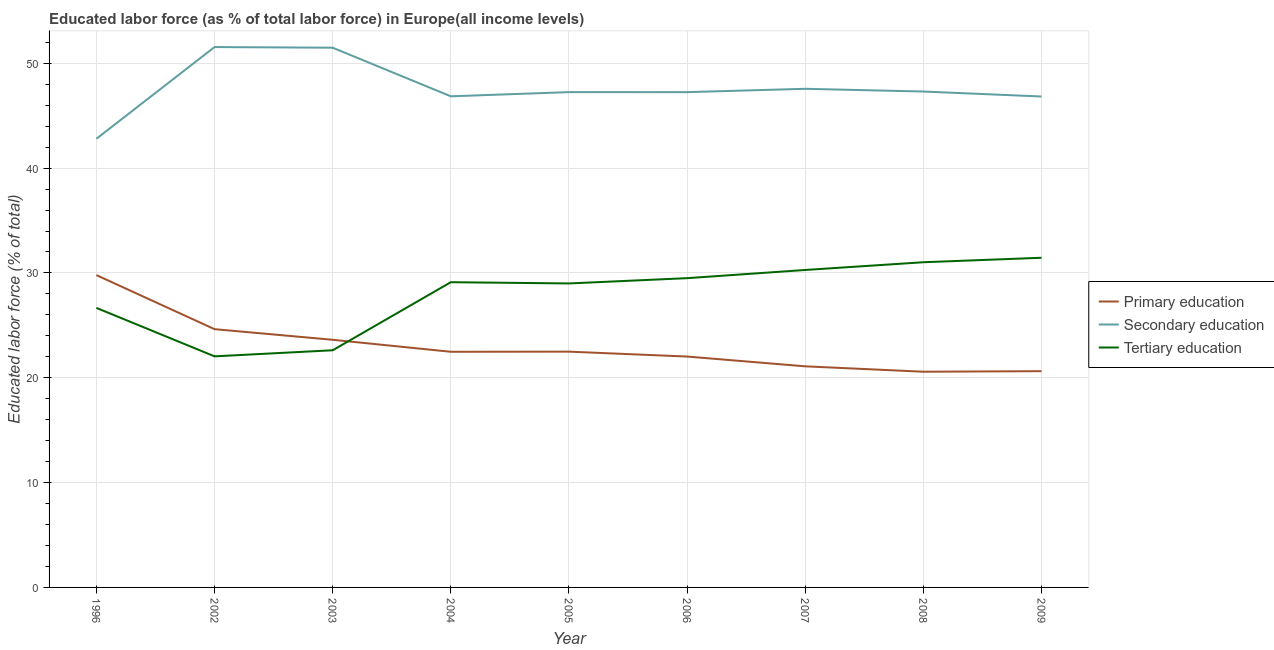How many different coloured lines are there?
Make the answer very short. 3. Is the number of lines equal to the number of legend labels?
Your answer should be very brief. Yes. What is the percentage of labor force who received tertiary education in 2005?
Your answer should be very brief. 29. Across all years, what is the maximum percentage of labor force who received tertiary education?
Offer a terse response. 31.45. Across all years, what is the minimum percentage of labor force who received tertiary education?
Offer a terse response. 22.04. In which year was the percentage of labor force who received primary education maximum?
Provide a succinct answer. 1996. What is the total percentage of labor force who received secondary education in the graph?
Offer a very short reply. 428.87. What is the difference between the percentage of labor force who received secondary education in 2002 and that in 2008?
Your response must be concise. 4.24. What is the difference between the percentage of labor force who received secondary education in 2008 and the percentage of labor force who received tertiary education in 2009?
Your answer should be compact. 15.86. What is the average percentage of labor force who received primary education per year?
Ensure brevity in your answer.  23.04. In the year 2004, what is the difference between the percentage of labor force who received secondary education and percentage of labor force who received tertiary education?
Your response must be concise. 17.73. In how many years, is the percentage of labor force who received secondary education greater than 50 %?
Ensure brevity in your answer.  2. What is the ratio of the percentage of labor force who received tertiary education in 2003 to that in 2004?
Your answer should be very brief. 0.78. Is the percentage of labor force who received secondary education in 2003 less than that in 2006?
Provide a short and direct response. No. What is the difference between the highest and the second highest percentage of labor force who received primary education?
Your answer should be very brief. 5.16. What is the difference between the highest and the lowest percentage of labor force who received primary education?
Make the answer very short. 9.22. In how many years, is the percentage of labor force who received secondary education greater than the average percentage of labor force who received secondary education taken over all years?
Your answer should be very brief. 2. Is the sum of the percentage of labor force who received secondary education in 1996 and 2008 greater than the maximum percentage of labor force who received primary education across all years?
Ensure brevity in your answer.  Yes. Is the percentage of labor force who received secondary education strictly less than the percentage of labor force who received tertiary education over the years?
Keep it short and to the point. No. How many lines are there?
Offer a very short reply. 3. What is the difference between two consecutive major ticks on the Y-axis?
Your answer should be compact. 10. Does the graph contain grids?
Your answer should be very brief. Yes. How many legend labels are there?
Your response must be concise. 3. What is the title of the graph?
Keep it short and to the point. Educated labor force (as % of total labor force) in Europe(all income levels). Does "Male employers" appear as one of the legend labels in the graph?
Offer a terse response. No. What is the label or title of the Y-axis?
Offer a very short reply. Educated labor force (% of total). What is the Educated labor force (% of total) of Primary education in 1996?
Offer a very short reply. 29.79. What is the Educated labor force (% of total) of Secondary education in 1996?
Your answer should be compact. 42.8. What is the Educated labor force (% of total) in Tertiary education in 1996?
Offer a very short reply. 26.66. What is the Educated labor force (% of total) of Primary education in 2002?
Offer a terse response. 24.64. What is the Educated labor force (% of total) of Secondary education in 2002?
Give a very brief answer. 51.55. What is the Educated labor force (% of total) in Tertiary education in 2002?
Your answer should be compact. 22.04. What is the Educated labor force (% of total) in Primary education in 2003?
Your answer should be compact. 23.62. What is the Educated labor force (% of total) in Secondary education in 2003?
Your response must be concise. 51.49. What is the Educated labor force (% of total) of Tertiary education in 2003?
Ensure brevity in your answer.  22.62. What is the Educated labor force (% of total) of Primary education in 2004?
Your answer should be compact. 22.48. What is the Educated labor force (% of total) of Secondary education in 2004?
Ensure brevity in your answer.  46.85. What is the Educated labor force (% of total) of Tertiary education in 2004?
Provide a succinct answer. 29.12. What is the Educated labor force (% of total) of Primary education in 2005?
Offer a very short reply. 22.49. What is the Educated labor force (% of total) of Secondary education in 2005?
Offer a very short reply. 47.25. What is the Educated labor force (% of total) of Tertiary education in 2005?
Make the answer very short. 29. What is the Educated labor force (% of total) of Primary education in 2006?
Provide a short and direct response. 22.02. What is the Educated labor force (% of total) in Secondary education in 2006?
Your answer should be compact. 47.25. What is the Educated labor force (% of total) of Tertiary education in 2006?
Your response must be concise. 29.5. What is the Educated labor force (% of total) of Primary education in 2007?
Keep it short and to the point. 21.09. What is the Educated labor force (% of total) of Secondary education in 2007?
Make the answer very short. 47.57. What is the Educated labor force (% of total) of Tertiary education in 2007?
Ensure brevity in your answer.  30.28. What is the Educated labor force (% of total) of Primary education in 2008?
Give a very brief answer. 20.58. What is the Educated labor force (% of total) in Secondary education in 2008?
Offer a terse response. 47.3. What is the Educated labor force (% of total) in Tertiary education in 2008?
Ensure brevity in your answer.  31.02. What is the Educated labor force (% of total) of Primary education in 2009?
Make the answer very short. 20.63. What is the Educated labor force (% of total) of Secondary education in 2009?
Provide a succinct answer. 46.83. What is the Educated labor force (% of total) of Tertiary education in 2009?
Provide a short and direct response. 31.45. Across all years, what is the maximum Educated labor force (% of total) of Primary education?
Provide a succinct answer. 29.79. Across all years, what is the maximum Educated labor force (% of total) in Secondary education?
Provide a succinct answer. 51.55. Across all years, what is the maximum Educated labor force (% of total) of Tertiary education?
Your answer should be very brief. 31.45. Across all years, what is the minimum Educated labor force (% of total) of Primary education?
Keep it short and to the point. 20.58. Across all years, what is the minimum Educated labor force (% of total) in Secondary education?
Ensure brevity in your answer.  42.8. Across all years, what is the minimum Educated labor force (% of total) of Tertiary education?
Provide a short and direct response. 22.04. What is the total Educated labor force (% of total) in Primary education in the graph?
Your response must be concise. 207.34. What is the total Educated labor force (% of total) of Secondary education in the graph?
Offer a very short reply. 428.87. What is the total Educated labor force (% of total) of Tertiary education in the graph?
Your answer should be very brief. 251.7. What is the difference between the Educated labor force (% of total) in Primary education in 1996 and that in 2002?
Provide a short and direct response. 5.16. What is the difference between the Educated labor force (% of total) in Secondary education in 1996 and that in 2002?
Give a very brief answer. -8.75. What is the difference between the Educated labor force (% of total) of Tertiary education in 1996 and that in 2002?
Keep it short and to the point. 4.62. What is the difference between the Educated labor force (% of total) in Primary education in 1996 and that in 2003?
Provide a succinct answer. 6.17. What is the difference between the Educated labor force (% of total) of Secondary education in 1996 and that in 2003?
Your response must be concise. -8.69. What is the difference between the Educated labor force (% of total) of Tertiary education in 1996 and that in 2003?
Provide a short and direct response. 4.04. What is the difference between the Educated labor force (% of total) of Primary education in 1996 and that in 2004?
Give a very brief answer. 7.31. What is the difference between the Educated labor force (% of total) of Secondary education in 1996 and that in 2004?
Keep it short and to the point. -4.05. What is the difference between the Educated labor force (% of total) in Tertiary education in 1996 and that in 2004?
Give a very brief answer. -2.45. What is the difference between the Educated labor force (% of total) of Primary education in 1996 and that in 2005?
Give a very brief answer. 7.3. What is the difference between the Educated labor force (% of total) of Secondary education in 1996 and that in 2005?
Provide a short and direct response. -4.45. What is the difference between the Educated labor force (% of total) of Tertiary education in 1996 and that in 2005?
Provide a short and direct response. -2.33. What is the difference between the Educated labor force (% of total) in Primary education in 1996 and that in 2006?
Your answer should be compact. 7.77. What is the difference between the Educated labor force (% of total) in Secondary education in 1996 and that in 2006?
Provide a short and direct response. -4.45. What is the difference between the Educated labor force (% of total) of Tertiary education in 1996 and that in 2006?
Ensure brevity in your answer.  -2.84. What is the difference between the Educated labor force (% of total) of Primary education in 1996 and that in 2007?
Make the answer very short. 8.7. What is the difference between the Educated labor force (% of total) in Secondary education in 1996 and that in 2007?
Provide a short and direct response. -4.77. What is the difference between the Educated labor force (% of total) in Tertiary education in 1996 and that in 2007?
Your answer should be very brief. -3.62. What is the difference between the Educated labor force (% of total) of Primary education in 1996 and that in 2008?
Your answer should be very brief. 9.22. What is the difference between the Educated labor force (% of total) of Secondary education in 1996 and that in 2008?
Your response must be concise. -4.51. What is the difference between the Educated labor force (% of total) of Tertiary education in 1996 and that in 2008?
Offer a very short reply. -4.36. What is the difference between the Educated labor force (% of total) of Primary education in 1996 and that in 2009?
Keep it short and to the point. 9.17. What is the difference between the Educated labor force (% of total) in Secondary education in 1996 and that in 2009?
Make the answer very short. -4.04. What is the difference between the Educated labor force (% of total) of Tertiary education in 1996 and that in 2009?
Your response must be concise. -4.78. What is the difference between the Educated labor force (% of total) in Primary education in 2002 and that in 2003?
Offer a terse response. 1.01. What is the difference between the Educated labor force (% of total) of Secondary education in 2002 and that in 2003?
Keep it short and to the point. 0.06. What is the difference between the Educated labor force (% of total) of Tertiary education in 2002 and that in 2003?
Keep it short and to the point. -0.58. What is the difference between the Educated labor force (% of total) in Primary education in 2002 and that in 2004?
Make the answer very short. 2.16. What is the difference between the Educated labor force (% of total) in Secondary education in 2002 and that in 2004?
Your response must be concise. 4.7. What is the difference between the Educated labor force (% of total) of Tertiary education in 2002 and that in 2004?
Keep it short and to the point. -7.07. What is the difference between the Educated labor force (% of total) in Primary education in 2002 and that in 2005?
Offer a very short reply. 2.14. What is the difference between the Educated labor force (% of total) of Secondary education in 2002 and that in 2005?
Provide a short and direct response. 4.3. What is the difference between the Educated labor force (% of total) in Tertiary education in 2002 and that in 2005?
Ensure brevity in your answer.  -6.95. What is the difference between the Educated labor force (% of total) of Primary education in 2002 and that in 2006?
Offer a very short reply. 2.61. What is the difference between the Educated labor force (% of total) in Secondary education in 2002 and that in 2006?
Your response must be concise. 4.3. What is the difference between the Educated labor force (% of total) of Tertiary education in 2002 and that in 2006?
Offer a very short reply. -7.46. What is the difference between the Educated labor force (% of total) of Primary education in 2002 and that in 2007?
Offer a terse response. 3.54. What is the difference between the Educated labor force (% of total) of Secondary education in 2002 and that in 2007?
Offer a terse response. 3.98. What is the difference between the Educated labor force (% of total) of Tertiary education in 2002 and that in 2007?
Ensure brevity in your answer.  -8.24. What is the difference between the Educated labor force (% of total) in Primary education in 2002 and that in 2008?
Provide a succinct answer. 4.06. What is the difference between the Educated labor force (% of total) in Secondary education in 2002 and that in 2008?
Offer a very short reply. 4.24. What is the difference between the Educated labor force (% of total) of Tertiary education in 2002 and that in 2008?
Offer a terse response. -8.98. What is the difference between the Educated labor force (% of total) of Primary education in 2002 and that in 2009?
Ensure brevity in your answer.  4.01. What is the difference between the Educated labor force (% of total) of Secondary education in 2002 and that in 2009?
Your answer should be compact. 4.72. What is the difference between the Educated labor force (% of total) in Tertiary education in 2002 and that in 2009?
Offer a terse response. -9.4. What is the difference between the Educated labor force (% of total) of Primary education in 2003 and that in 2004?
Keep it short and to the point. 1.14. What is the difference between the Educated labor force (% of total) of Secondary education in 2003 and that in 2004?
Your answer should be very brief. 4.64. What is the difference between the Educated labor force (% of total) of Tertiary education in 2003 and that in 2004?
Make the answer very short. -6.49. What is the difference between the Educated labor force (% of total) in Primary education in 2003 and that in 2005?
Provide a succinct answer. 1.13. What is the difference between the Educated labor force (% of total) in Secondary education in 2003 and that in 2005?
Give a very brief answer. 4.24. What is the difference between the Educated labor force (% of total) in Tertiary education in 2003 and that in 2005?
Ensure brevity in your answer.  -6.38. What is the difference between the Educated labor force (% of total) of Primary education in 2003 and that in 2006?
Make the answer very short. 1.6. What is the difference between the Educated labor force (% of total) in Secondary education in 2003 and that in 2006?
Offer a very short reply. 4.24. What is the difference between the Educated labor force (% of total) in Tertiary education in 2003 and that in 2006?
Your answer should be very brief. -6.88. What is the difference between the Educated labor force (% of total) of Primary education in 2003 and that in 2007?
Give a very brief answer. 2.53. What is the difference between the Educated labor force (% of total) of Secondary education in 2003 and that in 2007?
Give a very brief answer. 3.92. What is the difference between the Educated labor force (% of total) in Tertiary education in 2003 and that in 2007?
Your answer should be compact. -7.66. What is the difference between the Educated labor force (% of total) of Primary education in 2003 and that in 2008?
Your answer should be very brief. 3.05. What is the difference between the Educated labor force (% of total) in Secondary education in 2003 and that in 2008?
Offer a very short reply. 4.18. What is the difference between the Educated labor force (% of total) of Tertiary education in 2003 and that in 2008?
Your answer should be compact. -8.4. What is the difference between the Educated labor force (% of total) in Primary education in 2003 and that in 2009?
Your answer should be compact. 3. What is the difference between the Educated labor force (% of total) of Secondary education in 2003 and that in 2009?
Offer a terse response. 4.65. What is the difference between the Educated labor force (% of total) of Tertiary education in 2003 and that in 2009?
Ensure brevity in your answer.  -8.82. What is the difference between the Educated labor force (% of total) of Primary education in 2004 and that in 2005?
Make the answer very short. -0.01. What is the difference between the Educated labor force (% of total) of Secondary education in 2004 and that in 2005?
Provide a succinct answer. -0.4. What is the difference between the Educated labor force (% of total) in Tertiary education in 2004 and that in 2005?
Your answer should be compact. 0.12. What is the difference between the Educated labor force (% of total) in Primary education in 2004 and that in 2006?
Give a very brief answer. 0.46. What is the difference between the Educated labor force (% of total) of Secondary education in 2004 and that in 2006?
Provide a short and direct response. -0.4. What is the difference between the Educated labor force (% of total) of Tertiary education in 2004 and that in 2006?
Your answer should be compact. -0.38. What is the difference between the Educated labor force (% of total) of Primary education in 2004 and that in 2007?
Ensure brevity in your answer.  1.39. What is the difference between the Educated labor force (% of total) of Secondary education in 2004 and that in 2007?
Your answer should be very brief. -0.72. What is the difference between the Educated labor force (% of total) in Tertiary education in 2004 and that in 2007?
Ensure brevity in your answer.  -1.17. What is the difference between the Educated labor force (% of total) of Primary education in 2004 and that in 2008?
Provide a short and direct response. 1.9. What is the difference between the Educated labor force (% of total) in Secondary education in 2004 and that in 2008?
Offer a very short reply. -0.46. What is the difference between the Educated labor force (% of total) of Tertiary education in 2004 and that in 2008?
Offer a very short reply. -1.9. What is the difference between the Educated labor force (% of total) of Primary education in 2004 and that in 2009?
Keep it short and to the point. 1.85. What is the difference between the Educated labor force (% of total) of Secondary education in 2004 and that in 2009?
Provide a short and direct response. 0.02. What is the difference between the Educated labor force (% of total) in Tertiary education in 2004 and that in 2009?
Offer a very short reply. -2.33. What is the difference between the Educated labor force (% of total) of Primary education in 2005 and that in 2006?
Offer a very short reply. 0.47. What is the difference between the Educated labor force (% of total) in Secondary education in 2005 and that in 2006?
Offer a very short reply. 0. What is the difference between the Educated labor force (% of total) of Tertiary education in 2005 and that in 2006?
Make the answer very short. -0.5. What is the difference between the Educated labor force (% of total) of Primary education in 2005 and that in 2007?
Provide a short and direct response. 1.4. What is the difference between the Educated labor force (% of total) of Secondary education in 2005 and that in 2007?
Offer a very short reply. -0.32. What is the difference between the Educated labor force (% of total) in Tertiary education in 2005 and that in 2007?
Ensure brevity in your answer.  -1.28. What is the difference between the Educated labor force (% of total) of Primary education in 2005 and that in 2008?
Your answer should be very brief. 1.91. What is the difference between the Educated labor force (% of total) of Secondary education in 2005 and that in 2008?
Provide a short and direct response. -0.06. What is the difference between the Educated labor force (% of total) of Tertiary education in 2005 and that in 2008?
Your answer should be compact. -2.02. What is the difference between the Educated labor force (% of total) in Primary education in 2005 and that in 2009?
Give a very brief answer. 1.86. What is the difference between the Educated labor force (% of total) of Secondary education in 2005 and that in 2009?
Make the answer very short. 0.42. What is the difference between the Educated labor force (% of total) in Tertiary education in 2005 and that in 2009?
Give a very brief answer. -2.45. What is the difference between the Educated labor force (% of total) of Primary education in 2006 and that in 2007?
Provide a short and direct response. 0.93. What is the difference between the Educated labor force (% of total) in Secondary education in 2006 and that in 2007?
Provide a short and direct response. -0.32. What is the difference between the Educated labor force (% of total) of Tertiary education in 2006 and that in 2007?
Your response must be concise. -0.78. What is the difference between the Educated labor force (% of total) of Primary education in 2006 and that in 2008?
Ensure brevity in your answer.  1.45. What is the difference between the Educated labor force (% of total) in Secondary education in 2006 and that in 2008?
Provide a succinct answer. -0.06. What is the difference between the Educated labor force (% of total) in Tertiary education in 2006 and that in 2008?
Offer a terse response. -1.52. What is the difference between the Educated labor force (% of total) in Primary education in 2006 and that in 2009?
Ensure brevity in your answer.  1.4. What is the difference between the Educated labor force (% of total) of Secondary education in 2006 and that in 2009?
Ensure brevity in your answer.  0.42. What is the difference between the Educated labor force (% of total) in Tertiary education in 2006 and that in 2009?
Make the answer very short. -1.95. What is the difference between the Educated labor force (% of total) of Primary education in 2007 and that in 2008?
Your answer should be very brief. 0.51. What is the difference between the Educated labor force (% of total) of Secondary education in 2007 and that in 2008?
Offer a terse response. 0.26. What is the difference between the Educated labor force (% of total) of Tertiary education in 2007 and that in 2008?
Your answer should be compact. -0.74. What is the difference between the Educated labor force (% of total) in Primary education in 2007 and that in 2009?
Provide a short and direct response. 0.46. What is the difference between the Educated labor force (% of total) in Secondary education in 2007 and that in 2009?
Your answer should be very brief. 0.73. What is the difference between the Educated labor force (% of total) of Tertiary education in 2007 and that in 2009?
Make the answer very short. -1.16. What is the difference between the Educated labor force (% of total) in Primary education in 2008 and that in 2009?
Keep it short and to the point. -0.05. What is the difference between the Educated labor force (% of total) of Secondary education in 2008 and that in 2009?
Provide a succinct answer. 0.47. What is the difference between the Educated labor force (% of total) in Tertiary education in 2008 and that in 2009?
Offer a very short reply. -0.43. What is the difference between the Educated labor force (% of total) in Primary education in 1996 and the Educated labor force (% of total) in Secondary education in 2002?
Make the answer very short. -21.75. What is the difference between the Educated labor force (% of total) of Primary education in 1996 and the Educated labor force (% of total) of Tertiary education in 2002?
Offer a very short reply. 7.75. What is the difference between the Educated labor force (% of total) in Secondary education in 1996 and the Educated labor force (% of total) in Tertiary education in 2002?
Ensure brevity in your answer.  20.75. What is the difference between the Educated labor force (% of total) in Primary education in 1996 and the Educated labor force (% of total) in Secondary education in 2003?
Offer a terse response. -21.69. What is the difference between the Educated labor force (% of total) in Primary education in 1996 and the Educated labor force (% of total) in Tertiary education in 2003?
Make the answer very short. 7.17. What is the difference between the Educated labor force (% of total) of Secondary education in 1996 and the Educated labor force (% of total) of Tertiary education in 2003?
Your response must be concise. 20.17. What is the difference between the Educated labor force (% of total) in Primary education in 1996 and the Educated labor force (% of total) in Secondary education in 2004?
Provide a succinct answer. -17.05. What is the difference between the Educated labor force (% of total) in Primary education in 1996 and the Educated labor force (% of total) in Tertiary education in 2004?
Give a very brief answer. 0.68. What is the difference between the Educated labor force (% of total) of Secondary education in 1996 and the Educated labor force (% of total) of Tertiary education in 2004?
Keep it short and to the point. 13.68. What is the difference between the Educated labor force (% of total) in Primary education in 1996 and the Educated labor force (% of total) in Secondary education in 2005?
Your answer should be compact. -17.45. What is the difference between the Educated labor force (% of total) of Primary education in 1996 and the Educated labor force (% of total) of Tertiary education in 2005?
Your answer should be very brief. 0.8. What is the difference between the Educated labor force (% of total) in Secondary education in 1996 and the Educated labor force (% of total) in Tertiary education in 2005?
Make the answer very short. 13.8. What is the difference between the Educated labor force (% of total) of Primary education in 1996 and the Educated labor force (% of total) of Secondary education in 2006?
Your answer should be compact. -17.45. What is the difference between the Educated labor force (% of total) in Primary education in 1996 and the Educated labor force (% of total) in Tertiary education in 2006?
Ensure brevity in your answer.  0.29. What is the difference between the Educated labor force (% of total) in Secondary education in 1996 and the Educated labor force (% of total) in Tertiary education in 2006?
Your answer should be very brief. 13.3. What is the difference between the Educated labor force (% of total) in Primary education in 1996 and the Educated labor force (% of total) in Secondary education in 2007?
Your answer should be compact. -17.77. What is the difference between the Educated labor force (% of total) in Primary education in 1996 and the Educated labor force (% of total) in Tertiary education in 2007?
Keep it short and to the point. -0.49. What is the difference between the Educated labor force (% of total) in Secondary education in 1996 and the Educated labor force (% of total) in Tertiary education in 2007?
Keep it short and to the point. 12.51. What is the difference between the Educated labor force (% of total) of Primary education in 1996 and the Educated labor force (% of total) of Secondary education in 2008?
Make the answer very short. -17.51. What is the difference between the Educated labor force (% of total) in Primary education in 1996 and the Educated labor force (% of total) in Tertiary education in 2008?
Your answer should be compact. -1.23. What is the difference between the Educated labor force (% of total) of Secondary education in 1996 and the Educated labor force (% of total) of Tertiary education in 2008?
Your answer should be very brief. 11.78. What is the difference between the Educated labor force (% of total) in Primary education in 1996 and the Educated labor force (% of total) in Secondary education in 2009?
Give a very brief answer. -17.04. What is the difference between the Educated labor force (% of total) in Primary education in 1996 and the Educated labor force (% of total) in Tertiary education in 2009?
Offer a terse response. -1.65. What is the difference between the Educated labor force (% of total) in Secondary education in 1996 and the Educated labor force (% of total) in Tertiary education in 2009?
Give a very brief answer. 11.35. What is the difference between the Educated labor force (% of total) of Primary education in 2002 and the Educated labor force (% of total) of Secondary education in 2003?
Ensure brevity in your answer.  -26.85. What is the difference between the Educated labor force (% of total) in Primary education in 2002 and the Educated labor force (% of total) in Tertiary education in 2003?
Offer a very short reply. 2.01. What is the difference between the Educated labor force (% of total) in Secondary education in 2002 and the Educated labor force (% of total) in Tertiary education in 2003?
Give a very brief answer. 28.92. What is the difference between the Educated labor force (% of total) in Primary education in 2002 and the Educated labor force (% of total) in Secondary education in 2004?
Offer a terse response. -22.21. What is the difference between the Educated labor force (% of total) of Primary education in 2002 and the Educated labor force (% of total) of Tertiary education in 2004?
Make the answer very short. -4.48. What is the difference between the Educated labor force (% of total) in Secondary education in 2002 and the Educated labor force (% of total) in Tertiary education in 2004?
Provide a succinct answer. 22.43. What is the difference between the Educated labor force (% of total) of Primary education in 2002 and the Educated labor force (% of total) of Secondary education in 2005?
Provide a succinct answer. -22.61. What is the difference between the Educated labor force (% of total) in Primary education in 2002 and the Educated labor force (% of total) in Tertiary education in 2005?
Make the answer very short. -4.36. What is the difference between the Educated labor force (% of total) in Secondary education in 2002 and the Educated labor force (% of total) in Tertiary education in 2005?
Offer a very short reply. 22.55. What is the difference between the Educated labor force (% of total) of Primary education in 2002 and the Educated labor force (% of total) of Secondary education in 2006?
Offer a very short reply. -22.61. What is the difference between the Educated labor force (% of total) in Primary education in 2002 and the Educated labor force (% of total) in Tertiary education in 2006?
Ensure brevity in your answer.  -4.86. What is the difference between the Educated labor force (% of total) of Secondary education in 2002 and the Educated labor force (% of total) of Tertiary education in 2006?
Provide a succinct answer. 22.05. What is the difference between the Educated labor force (% of total) of Primary education in 2002 and the Educated labor force (% of total) of Secondary education in 2007?
Ensure brevity in your answer.  -22.93. What is the difference between the Educated labor force (% of total) in Primary education in 2002 and the Educated labor force (% of total) in Tertiary education in 2007?
Your answer should be very brief. -5.65. What is the difference between the Educated labor force (% of total) of Secondary education in 2002 and the Educated labor force (% of total) of Tertiary education in 2007?
Offer a very short reply. 21.26. What is the difference between the Educated labor force (% of total) in Primary education in 2002 and the Educated labor force (% of total) in Secondary education in 2008?
Keep it short and to the point. -22.67. What is the difference between the Educated labor force (% of total) in Primary education in 2002 and the Educated labor force (% of total) in Tertiary education in 2008?
Offer a very short reply. -6.38. What is the difference between the Educated labor force (% of total) of Secondary education in 2002 and the Educated labor force (% of total) of Tertiary education in 2008?
Offer a terse response. 20.53. What is the difference between the Educated labor force (% of total) of Primary education in 2002 and the Educated labor force (% of total) of Secondary education in 2009?
Your response must be concise. -22.2. What is the difference between the Educated labor force (% of total) in Primary education in 2002 and the Educated labor force (% of total) in Tertiary education in 2009?
Keep it short and to the point. -6.81. What is the difference between the Educated labor force (% of total) in Secondary education in 2002 and the Educated labor force (% of total) in Tertiary education in 2009?
Ensure brevity in your answer.  20.1. What is the difference between the Educated labor force (% of total) in Primary education in 2003 and the Educated labor force (% of total) in Secondary education in 2004?
Give a very brief answer. -23.22. What is the difference between the Educated labor force (% of total) in Primary education in 2003 and the Educated labor force (% of total) in Tertiary education in 2004?
Give a very brief answer. -5.49. What is the difference between the Educated labor force (% of total) of Secondary education in 2003 and the Educated labor force (% of total) of Tertiary education in 2004?
Keep it short and to the point. 22.37. What is the difference between the Educated labor force (% of total) in Primary education in 2003 and the Educated labor force (% of total) in Secondary education in 2005?
Ensure brevity in your answer.  -23.62. What is the difference between the Educated labor force (% of total) in Primary education in 2003 and the Educated labor force (% of total) in Tertiary education in 2005?
Your response must be concise. -5.37. What is the difference between the Educated labor force (% of total) in Secondary education in 2003 and the Educated labor force (% of total) in Tertiary education in 2005?
Provide a succinct answer. 22.49. What is the difference between the Educated labor force (% of total) of Primary education in 2003 and the Educated labor force (% of total) of Secondary education in 2006?
Offer a very short reply. -23.62. What is the difference between the Educated labor force (% of total) in Primary education in 2003 and the Educated labor force (% of total) in Tertiary education in 2006?
Give a very brief answer. -5.88. What is the difference between the Educated labor force (% of total) of Secondary education in 2003 and the Educated labor force (% of total) of Tertiary education in 2006?
Your answer should be compact. 21.98. What is the difference between the Educated labor force (% of total) of Primary education in 2003 and the Educated labor force (% of total) of Secondary education in 2007?
Make the answer very short. -23.94. What is the difference between the Educated labor force (% of total) in Primary education in 2003 and the Educated labor force (% of total) in Tertiary education in 2007?
Offer a terse response. -6.66. What is the difference between the Educated labor force (% of total) of Secondary education in 2003 and the Educated labor force (% of total) of Tertiary education in 2007?
Offer a very short reply. 21.2. What is the difference between the Educated labor force (% of total) in Primary education in 2003 and the Educated labor force (% of total) in Secondary education in 2008?
Offer a very short reply. -23.68. What is the difference between the Educated labor force (% of total) of Primary education in 2003 and the Educated labor force (% of total) of Tertiary education in 2008?
Your response must be concise. -7.4. What is the difference between the Educated labor force (% of total) of Secondary education in 2003 and the Educated labor force (% of total) of Tertiary education in 2008?
Provide a succinct answer. 20.46. What is the difference between the Educated labor force (% of total) in Primary education in 2003 and the Educated labor force (% of total) in Secondary education in 2009?
Your answer should be very brief. -23.21. What is the difference between the Educated labor force (% of total) of Primary education in 2003 and the Educated labor force (% of total) of Tertiary education in 2009?
Provide a succinct answer. -7.82. What is the difference between the Educated labor force (% of total) in Secondary education in 2003 and the Educated labor force (% of total) in Tertiary education in 2009?
Offer a terse response. 20.04. What is the difference between the Educated labor force (% of total) of Primary education in 2004 and the Educated labor force (% of total) of Secondary education in 2005?
Provide a short and direct response. -24.77. What is the difference between the Educated labor force (% of total) of Primary education in 2004 and the Educated labor force (% of total) of Tertiary education in 2005?
Keep it short and to the point. -6.52. What is the difference between the Educated labor force (% of total) in Secondary education in 2004 and the Educated labor force (% of total) in Tertiary education in 2005?
Your response must be concise. 17.85. What is the difference between the Educated labor force (% of total) of Primary education in 2004 and the Educated labor force (% of total) of Secondary education in 2006?
Give a very brief answer. -24.77. What is the difference between the Educated labor force (% of total) of Primary education in 2004 and the Educated labor force (% of total) of Tertiary education in 2006?
Offer a very short reply. -7.02. What is the difference between the Educated labor force (% of total) of Secondary education in 2004 and the Educated labor force (% of total) of Tertiary education in 2006?
Make the answer very short. 17.35. What is the difference between the Educated labor force (% of total) in Primary education in 2004 and the Educated labor force (% of total) in Secondary education in 2007?
Provide a short and direct response. -25.09. What is the difference between the Educated labor force (% of total) of Primary education in 2004 and the Educated labor force (% of total) of Tertiary education in 2007?
Ensure brevity in your answer.  -7.8. What is the difference between the Educated labor force (% of total) in Secondary education in 2004 and the Educated labor force (% of total) in Tertiary education in 2007?
Offer a terse response. 16.56. What is the difference between the Educated labor force (% of total) in Primary education in 2004 and the Educated labor force (% of total) in Secondary education in 2008?
Make the answer very short. -24.83. What is the difference between the Educated labor force (% of total) of Primary education in 2004 and the Educated labor force (% of total) of Tertiary education in 2008?
Provide a succinct answer. -8.54. What is the difference between the Educated labor force (% of total) in Secondary education in 2004 and the Educated labor force (% of total) in Tertiary education in 2008?
Give a very brief answer. 15.83. What is the difference between the Educated labor force (% of total) of Primary education in 2004 and the Educated labor force (% of total) of Secondary education in 2009?
Your answer should be compact. -24.35. What is the difference between the Educated labor force (% of total) in Primary education in 2004 and the Educated labor force (% of total) in Tertiary education in 2009?
Give a very brief answer. -8.97. What is the difference between the Educated labor force (% of total) in Secondary education in 2004 and the Educated labor force (% of total) in Tertiary education in 2009?
Keep it short and to the point. 15.4. What is the difference between the Educated labor force (% of total) in Primary education in 2005 and the Educated labor force (% of total) in Secondary education in 2006?
Provide a short and direct response. -24.76. What is the difference between the Educated labor force (% of total) in Primary education in 2005 and the Educated labor force (% of total) in Tertiary education in 2006?
Provide a succinct answer. -7.01. What is the difference between the Educated labor force (% of total) of Secondary education in 2005 and the Educated labor force (% of total) of Tertiary education in 2006?
Make the answer very short. 17.75. What is the difference between the Educated labor force (% of total) in Primary education in 2005 and the Educated labor force (% of total) in Secondary education in 2007?
Give a very brief answer. -25.07. What is the difference between the Educated labor force (% of total) in Primary education in 2005 and the Educated labor force (% of total) in Tertiary education in 2007?
Keep it short and to the point. -7.79. What is the difference between the Educated labor force (% of total) in Secondary education in 2005 and the Educated labor force (% of total) in Tertiary education in 2007?
Ensure brevity in your answer.  16.97. What is the difference between the Educated labor force (% of total) in Primary education in 2005 and the Educated labor force (% of total) in Secondary education in 2008?
Your response must be concise. -24.81. What is the difference between the Educated labor force (% of total) in Primary education in 2005 and the Educated labor force (% of total) in Tertiary education in 2008?
Keep it short and to the point. -8.53. What is the difference between the Educated labor force (% of total) in Secondary education in 2005 and the Educated labor force (% of total) in Tertiary education in 2008?
Offer a terse response. 16.23. What is the difference between the Educated labor force (% of total) of Primary education in 2005 and the Educated labor force (% of total) of Secondary education in 2009?
Make the answer very short. -24.34. What is the difference between the Educated labor force (% of total) of Primary education in 2005 and the Educated labor force (% of total) of Tertiary education in 2009?
Provide a short and direct response. -8.96. What is the difference between the Educated labor force (% of total) of Secondary education in 2005 and the Educated labor force (% of total) of Tertiary education in 2009?
Provide a short and direct response. 15.8. What is the difference between the Educated labor force (% of total) in Primary education in 2006 and the Educated labor force (% of total) in Secondary education in 2007?
Your answer should be very brief. -25.54. What is the difference between the Educated labor force (% of total) of Primary education in 2006 and the Educated labor force (% of total) of Tertiary education in 2007?
Provide a succinct answer. -8.26. What is the difference between the Educated labor force (% of total) of Secondary education in 2006 and the Educated labor force (% of total) of Tertiary education in 2007?
Offer a very short reply. 16.96. What is the difference between the Educated labor force (% of total) of Primary education in 2006 and the Educated labor force (% of total) of Secondary education in 2008?
Your response must be concise. -25.28. What is the difference between the Educated labor force (% of total) of Primary education in 2006 and the Educated labor force (% of total) of Tertiary education in 2008?
Offer a very short reply. -9. What is the difference between the Educated labor force (% of total) in Secondary education in 2006 and the Educated labor force (% of total) in Tertiary education in 2008?
Make the answer very short. 16.23. What is the difference between the Educated labor force (% of total) in Primary education in 2006 and the Educated labor force (% of total) in Secondary education in 2009?
Offer a very short reply. -24.81. What is the difference between the Educated labor force (% of total) of Primary education in 2006 and the Educated labor force (% of total) of Tertiary education in 2009?
Offer a very short reply. -9.42. What is the difference between the Educated labor force (% of total) in Secondary education in 2006 and the Educated labor force (% of total) in Tertiary education in 2009?
Provide a succinct answer. 15.8. What is the difference between the Educated labor force (% of total) in Primary education in 2007 and the Educated labor force (% of total) in Secondary education in 2008?
Make the answer very short. -26.21. What is the difference between the Educated labor force (% of total) in Primary education in 2007 and the Educated labor force (% of total) in Tertiary education in 2008?
Make the answer very short. -9.93. What is the difference between the Educated labor force (% of total) in Secondary education in 2007 and the Educated labor force (% of total) in Tertiary education in 2008?
Keep it short and to the point. 16.55. What is the difference between the Educated labor force (% of total) in Primary education in 2007 and the Educated labor force (% of total) in Secondary education in 2009?
Your answer should be compact. -25.74. What is the difference between the Educated labor force (% of total) of Primary education in 2007 and the Educated labor force (% of total) of Tertiary education in 2009?
Offer a terse response. -10.36. What is the difference between the Educated labor force (% of total) in Secondary education in 2007 and the Educated labor force (% of total) in Tertiary education in 2009?
Offer a very short reply. 16.12. What is the difference between the Educated labor force (% of total) of Primary education in 2008 and the Educated labor force (% of total) of Secondary education in 2009?
Offer a very short reply. -26.25. What is the difference between the Educated labor force (% of total) of Primary education in 2008 and the Educated labor force (% of total) of Tertiary education in 2009?
Provide a succinct answer. -10.87. What is the difference between the Educated labor force (% of total) of Secondary education in 2008 and the Educated labor force (% of total) of Tertiary education in 2009?
Offer a very short reply. 15.86. What is the average Educated labor force (% of total) in Primary education per year?
Provide a succinct answer. 23.04. What is the average Educated labor force (% of total) in Secondary education per year?
Offer a very short reply. 47.65. What is the average Educated labor force (% of total) of Tertiary education per year?
Offer a terse response. 27.97. In the year 1996, what is the difference between the Educated labor force (% of total) of Primary education and Educated labor force (% of total) of Secondary education?
Make the answer very short. -13. In the year 1996, what is the difference between the Educated labor force (% of total) in Primary education and Educated labor force (% of total) in Tertiary education?
Give a very brief answer. 3.13. In the year 1996, what is the difference between the Educated labor force (% of total) in Secondary education and Educated labor force (% of total) in Tertiary education?
Your response must be concise. 16.13. In the year 2002, what is the difference between the Educated labor force (% of total) of Primary education and Educated labor force (% of total) of Secondary education?
Offer a very short reply. -26.91. In the year 2002, what is the difference between the Educated labor force (% of total) in Primary education and Educated labor force (% of total) in Tertiary education?
Keep it short and to the point. 2.59. In the year 2002, what is the difference between the Educated labor force (% of total) in Secondary education and Educated labor force (% of total) in Tertiary education?
Provide a succinct answer. 29.5. In the year 2003, what is the difference between the Educated labor force (% of total) in Primary education and Educated labor force (% of total) in Secondary education?
Offer a terse response. -27.86. In the year 2003, what is the difference between the Educated labor force (% of total) of Secondary education and Educated labor force (% of total) of Tertiary education?
Provide a succinct answer. 28.86. In the year 2004, what is the difference between the Educated labor force (% of total) of Primary education and Educated labor force (% of total) of Secondary education?
Your answer should be compact. -24.37. In the year 2004, what is the difference between the Educated labor force (% of total) of Primary education and Educated labor force (% of total) of Tertiary education?
Your answer should be compact. -6.64. In the year 2004, what is the difference between the Educated labor force (% of total) in Secondary education and Educated labor force (% of total) in Tertiary education?
Make the answer very short. 17.73. In the year 2005, what is the difference between the Educated labor force (% of total) of Primary education and Educated labor force (% of total) of Secondary education?
Provide a short and direct response. -24.76. In the year 2005, what is the difference between the Educated labor force (% of total) of Primary education and Educated labor force (% of total) of Tertiary education?
Give a very brief answer. -6.51. In the year 2005, what is the difference between the Educated labor force (% of total) in Secondary education and Educated labor force (% of total) in Tertiary education?
Offer a very short reply. 18.25. In the year 2006, what is the difference between the Educated labor force (% of total) in Primary education and Educated labor force (% of total) in Secondary education?
Provide a short and direct response. -25.22. In the year 2006, what is the difference between the Educated labor force (% of total) in Primary education and Educated labor force (% of total) in Tertiary education?
Your answer should be compact. -7.48. In the year 2006, what is the difference between the Educated labor force (% of total) in Secondary education and Educated labor force (% of total) in Tertiary education?
Give a very brief answer. 17.75. In the year 2007, what is the difference between the Educated labor force (% of total) in Primary education and Educated labor force (% of total) in Secondary education?
Offer a terse response. -26.47. In the year 2007, what is the difference between the Educated labor force (% of total) of Primary education and Educated labor force (% of total) of Tertiary education?
Provide a succinct answer. -9.19. In the year 2007, what is the difference between the Educated labor force (% of total) in Secondary education and Educated labor force (% of total) in Tertiary education?
Your response must be concise. 17.28. In the year 2008, what is the difference between the Educated labor force (% of total) in Primary education and Educated labor force (% of total) in Secondary education?
Make the answer very short. -26.73. In the year 2008, what is the difference between the Educated labor force (% of total) of Primary education and Educated labor force (% of total) of Tertiary education?
Your answer should be very brief. -10.44. In the year 2008, what is the difference between the Educated labor force (% of total) in Secondary education and Educated labor force (% of total) in Tertiary education?
Your answer should be compact. 16.28. In the year 2009, what is the difference between the Educated labor force (% of total) in Primary education and Educated labor force (% of total) in Secondary education?
Ensure brevity in your answer.  -26.2. In the year 2009, what is the difference between the Educated labor force (% of total) in Primary education and Educated labor force (% of total) in Tertiary education?
Provide a succinct answer. -10.82. In the year 2009, what is the difference between the Educated labor force (% of total) in Secondary education and Educated labor force (% of total) in Tertiary education?
Make the answer very short. 15.38. What is the ratio of the Educated labor force (% of total) of Primary education in 1996 to that in 2002?
Make the answer very short. 1.21. What is the ratio of the Educated labor force (% of total) in Secondary education in 1996 to that in 2002?
Ensure brevity in your answer.  0.83. What is the ratio of the Educated labor force (% of total) in Tertiary education in 1996 to that in 2002?
Ensure brevity in your answer.  1.21. What is the ratio of the Educated labor force (% of total) of Primary education in 1996 to that in 2003?
Your answer should be very brief. 1.26. What is the ratio of the Educated labor force (% of total) in Secondary education in 1996 to that in 2003?
Your answer should be very brief. 0.83. What is the ratio of the Educated labor force (% of total) of Tertiary education in 1996 to that in 2003?
Make the answer very short. 1.18. What is the ratio of the Educated labor force (% of total) of Primary education in 1996 to that in 2004?
Offer a terse response. 1.33. What is the ratio of the Educated labor force (% of total) in Secondary education in 1996 to that in 2004?
Provide a succinct answer. 0.91. What is the ratio of the Educated labor force (% of total) in Tertiary education in 1996 to that in 2004?
Your answer should be compact. 0.92. What is the ratio of the Educated labor force (% of total) of Primary education in 1996 to that in 2005?
Provide a short and direct response. 1.32. What is the ratio of the Educated labor force (% of total) in Secondary education in 1996 to that in 2005?
Keep it short and to the point. 0.91. What is the ratio of the Educated labor force (% of total) of Tertiary education in 1996 to that in 2005?
Provide a succinct answer. 0.92. What is the ratio of the Educated labor force (% of total) in Primary education in 1996 to that in 2006?
Provide a short and direct response. 1.35. What is the ratio of the Educated labor force (% of total) in Secondary education in 1996 to that in 2006?
Your answer should be very brief. 0.91. What is the ratio of the Educated labor force (% of total) in Tertiary education in 1996 to that in 2006?
Your response must be concise. 0.9. What is the ratio of the Educated labor force (% of total) in Primary education in 1996 to that in 2007?
Offer a very short reply. 1.41. What is the ratio of the Educated labor force (% of total) in Secondary education in 1996 to that in 2007?
Make the answer very short. 0.9. What is the ratio of the Educated labor force (% of total) of Tertiary education in 1996 to that in 2007?
Make the answer very short. 0.88. What is the ratio of the Educated labor force (% of total) in Primary education in 1996 to that in 2008?
Offer a very short reply. 1.45. What is the ratio of the Educated labor force (% of total) of Secondary education in 1996 to that in 2008?
Your answer should be compact. 0.9. What is the ratio of the Educated labor force (% of total) of Tertiary education in 1996 to that in 2008?
Offer a terse response. 0.86. What is the ratio of the Educated labor force (% of total) of Primary education in 1996 to that in 2009?
Make the answer very short. 1.44. What is the ratio of the Educated labor force (% of total) in Secondary education in 1996 to that in 2009?
Your response must be concise. 0.91. What is the ratio of the Educated labor force (% of total) of Tertiary education in 1996 to that in 2009?
Your answer should be very brief. 0.85. What is the ratio of the Educated labor force (% of total) in Primary education in 2002 to that in 2003?
Your response must be concise. 1.04. What is the ratio of the Educated labor force (% of total) in Secondary education in 2002 to that in 2003?
Provide a succinct answer. 1. What is the ratio of the Educated labor force (% of total) of Tertiary education in 2002 to that in 2003?
Make the answer very short. 0.97. What is the ratio of the Educated labor force (% of total) of Primary education in 2002 to that in 2004?
Offer a very short reply. 1.1. What is the ratio of the Educated labor force (% of total) of Secondary education in 2002 to that in 2004?
Provide a succinct answer. 1.1. What is the ratio of the Educated labor force (% of total) of Tertiary education in 2002 to that in 2004?
Offer a very short reply. 0.76. What is the ratio of the Educated labor force (% of total) of Primary education in 2002 to that in 2005?
Give a very brief answer. 1.1. What is the ratio of the Educated labor force (% of total) in Secondary education in 2002 to that in 2005?
Make the answer very short. 1.09. What is the ratio of the Educated labor force (% of total) in Tertiary education in 2002 to that in 2005?
Your answer should be compact. 0.76. What is the ratio of the Educated labor force (% of total) of Primary education in 2002 to that in 2006?
Keep it short and to the point. 1.12. What is the ratio of the Educated labor force (% of total) of Secondary education in 2002 to that in 2006?
Make the answer very short. 1.09. What is the ratio of the Educated labor force (% of total) of Tertiary education in 2002 to that in 2006?
Give a very brief answer. 0.75. What is the ratio of the Educated labor force (% of total) in Primary education in 2002 to that in 2007?
Provide a succinct answer. 1.17. What is the ratio of the Educated labor force (% of total) in Secondary education in 2002 to that in 2007?
Provide a short and direct response. 1.08. What is the ratio of the Educated labor force (% of total) of Tertiary education in 2002 to that in 2007?
Ensure brevity in your answer.  0.73. What is the ratio of the Educated labor force (% of total) of Primary education in 2002 to that in 2008?
Make the answer very short. 1.2. What is the ratio of the Educated labor force (% of total) in Secondary education in 2002 to that in 2008?
Make the answer very short. 1.09. What is the ratio of the Educated labor force (% of total) of Tertiary education in 2002 to that in 2008?
Give a very brief answer. 0.71. What is the ratio of the Educated labor force (% of total) in Primary education in 2002 to that in 2009?
Provide a short and direct response. 1.19. What is the ratio of the Educated labor force (% of total) of Secondary education in 2002 to that in 2009?
Ensure brevity in your answer.  1.1. What is the ratio of the Educated labor force (% of total) in Tertiary education in 2002 to that in 2009?
Keep it short and to the point. 0.7. What is the ratio of the Educated labor force (% of total) of Primary education in 2003 to that in 2004?
Make the answer very short. 1.05. What is the ratio of the Educated labor force (% of total) in Secondary education in 2003 to that in 2004?
Keep it short and to the point. 1.1. What is the ratio of the Educated labor force (% of total) in Tertiary education in 2003 to that in 2004?
Make the answer very short. 0.78. What is the ratio of the Educated labor force (% of total) in Primary education in 2003 to that in 2005?
Give a very brief answer. 1.05. What is the ratio of the Educated labor force (% of total) in Secondary education in 2003 to that in 2005?
Provide a short and direct response. 1.09. What is the ratio of the Educated labor force (% of total) of Tertiary education in 2003 to that in 2005?
Your response must be concise. 0.78. What is the ratio of the Educated labor force (% of total) of Primary education in 2003 to that in 2006?
Offer a very short reply. 1.07. What is the ratio of the Educated labor force (% of total) of Secondary education in 2003 to that in 2006?
Ensure brevity in your answer.  1.09. What is the ratio of the Educated labor force (% of total) of Tertiary education in 2003 to that in 2006?
Provide a succinct answer. 0.77. What is the ratio of the Educated labor force (% of total) in Primary education in 2003 to that in 2007?
Provide a succinct answer. 1.12. What is the ratio of the Educated labor force (% of total) of Secondary education in 2003 to that in 2007?
Offer a very short reply. 1.08. What is the ratio of the Educated labor force (% of total) of Tertiary education in 2003 to that in 2007?
Ensure brevity in your answer.  0.75. What is the ratio of the Educated labor force (% of total) of Primary education in 2003 to that in 2008?
Keep it short and to the point. 1.15. What is the ratio of the Educated labor force (% of total) in Secondary education in 2003 to that in 2008?
Your answer should be very brief. 1.09. What is the ratio of the Educated labor force (% of total) of Tertiary education in 2003 to that in 2008?
Ensure brevity in your answer.  0.73. What is the ratio of the Educated labor force (% of total) in Primary education in 2003 to that in 2009?
Keep it short and to the point. 1.15. What is the ratio of the Educated labor force (% of total) of Secondary education in 2003 to that in 2009?
Provide a succinct answer. 1.1. What is the ratio of the Educated labor force (% of total) of Tertiary education in 2003 to that in 2009?
Your answer should be compact. 0.72. What is the ratio of the Educated labor force (% of total) in Secondary education in 2004 to that in 2005?
Your response must be concise. 0.99. What is the ratio of the Educated labor force (% of total) of Tertiary education in 2004 to that in 2005?
Give a very brief answer. 1. What is the ratio of the Educated labor force (% of total) in Primary education in 2004 to that in 2006?
Offer a terse response. 1.02. What is the ratio of the Educated labor force (% of total) of Secondary education in 2004 to that in 2006?
Give a very brief answer. 0.99. What is the ratio of the Educated labor force (% of total) in Tertiary education in 2004 to that in 2006?
Offer a terse response. 0.99. What is the ratio of the Educated labor force (% of total) of Primary education in 2004 to that in 2007?
Keep it short and to the point. 1.07. What is the ratio of the Educated labor force (% of total) of Secondary education in 2004 to that in 2007?
Keep it short and to the point. 0.98. What is the ratio of the Educated labor force (% of total) in Tertiary education in 2004 to that in 2007?
Offer a very short reply. 0.96. What is the ratio of the Educated labor force (% of total) of Primary education in 2004 to that in 2008?
Your answer should be compact. 1.09. What is the ratio of the Educated labor force (% of total) of Secondary education in 2004 to that in 2008?
Your answer should be compact. 0.99. What is the ratio of the Educated labor force (% of total) of Tertiary education in 2004 to that in 2008?
Give a very brief answer. 0.94. What is the ratio of the Educated labor force (% of total) of Primary education in 2004 to that in 2009?
Offer a very short reply. 1.09. What is the ratio of the Educated labor force (% of total) in Secondary education in 2004 to that in 2009?
Give a very brief answer. 1. What is the ratio of the Educated labor force (% of total) in Tertiary education in 2004 to that in 2009?
Make the answer very short. 0.93. What is the ratio of the Educated labor force (% of total) in Primary education in 2005 to that in 2006?
Keep it short and to the point. 1.02. What is the ratio of the Educated labor force (% of total) of Primary education in 2005 to that in 2007?
Your answer should be compact. 1.07. What is the ratio of the Educated labor force (% of total) of Secondary education in 2005 to that in 2007?
Ensure brevity in your answer.  0.99. What is the ratio of the Educated labor force (% of total) of Tertiary education in 2005 to that in 2007?
Provide a short and direct response. 0.96. What is the ratio of the Educated labor force (% of total) in Primary education in 2005 to that in 2008?
Your answer should be very brief. 1.09. What is the ratio of the Educated labor force (% of total) in Tertiary education in 2005 to that in 2008?
Ensure brevity in your answer.  0.93. What is the ratio of the Educated labor force (% of total) of Primary education in 2005 to that in 2009?
Give a very brief answer. 1.09. What is the ratio of the Educated labor force (% of total) in Secondary education in 2005 to that in 2009?
Provide a succinct answer. 1.01. What is the ratio of the Educated labor force (% of total) of Tertiary education in 2005 to that in 2009?
Your response must be concise. 0.92. What is the ratio of the Educated labor force (% of total) in Primary education in 2006 to that in 2007?
Offer a terse response. 1.04. What is the ratio of the Educated labor force (% of total) of Secondary education in 2006 to that in 2007?
Ensure brevity in your answer.  0.99. What is the ratio of the Educated labor force (% of total) in Tertiary education in 2006 to that in 2007?
Provide a succinct answer. 0.97. What is the ratio of the Educated labor force (% of total) of Primary education in 2006 to that in 2008?
Your response must be concise. 1.07. What is the ratio of the Educated labor force (% of total) in Tertiary education in 2006 to that in 2008?
Make the answer very short. 0.95. What is the ratio of the Educated labor force (% of total) of Primary education in 2006 to that in 2009?
Ensure brevity in your answer.  1.07. What is the ratio of the Educated labor force (% of total) in Secondary education in 2006 to that in 2009?
Keep it short and to the point. 1.01. What is the ratio of the Educated labor force (% of total) of Tertiary education in 2006 to that in 2009?
Keep it short and to the point. 0.94. What is the ratio of the Educated labor force (% of total) of Secondary education in 2007 to that in 2008?
Offer a terse response. 1.01. What is the ratio of the Educated labor force (% of total) in Tertiary education in 2007 to that in 2008?
Make the answer very short. 0.98. What is the ratio of the Educated labor force (% of total) of Primary education in 2007 to that in 2009?
Make the answer very short. 1.02. What is the ratio of the Educated labor force (% of total) in Secondary education in 2007 to that in 2009?
Keep it short and to the point. 1.02. What is the ratio of the Educated labor force (% of total) of Primary education in 2008 to that in 2009?
Your answer should be compact. 1. What is the ratio of the Educated labor force (% of total) in Secondary education in 2008 to that in 2009?
Offer a terse response. 1.01. What is the ratio of the Educated labor force (% of total) in Tertiary education in 2008 to that in 2009?
Give a very brief answer. 0.99. What is the difference between the highest and the second highest Educated labor force (% of total) of Primary education?
Provide a short and direct response. 5.16. What is the difference between the highest and the second highest Educated labor force (% of total) in Secondary education?
Keep it short and to the point. 0.06. What is the difference between the highest and the second highest Educated labor force (% of total) of Tertiary education?
Your answer should be very brief. 0.43. What is the difference between the highest and the lowest Educated labor force (% of total) of Primary education?
Offer a terse response. 9.22. What is the difference between the highest and the lowest Educated labor force (% of total) of Secondary education?
Offer a very short reply. 8.75. What is the difference between the highest and the lowest Educated labor force (% of total) in Tertiary education?
Your answer should be very brief. 9.4. 